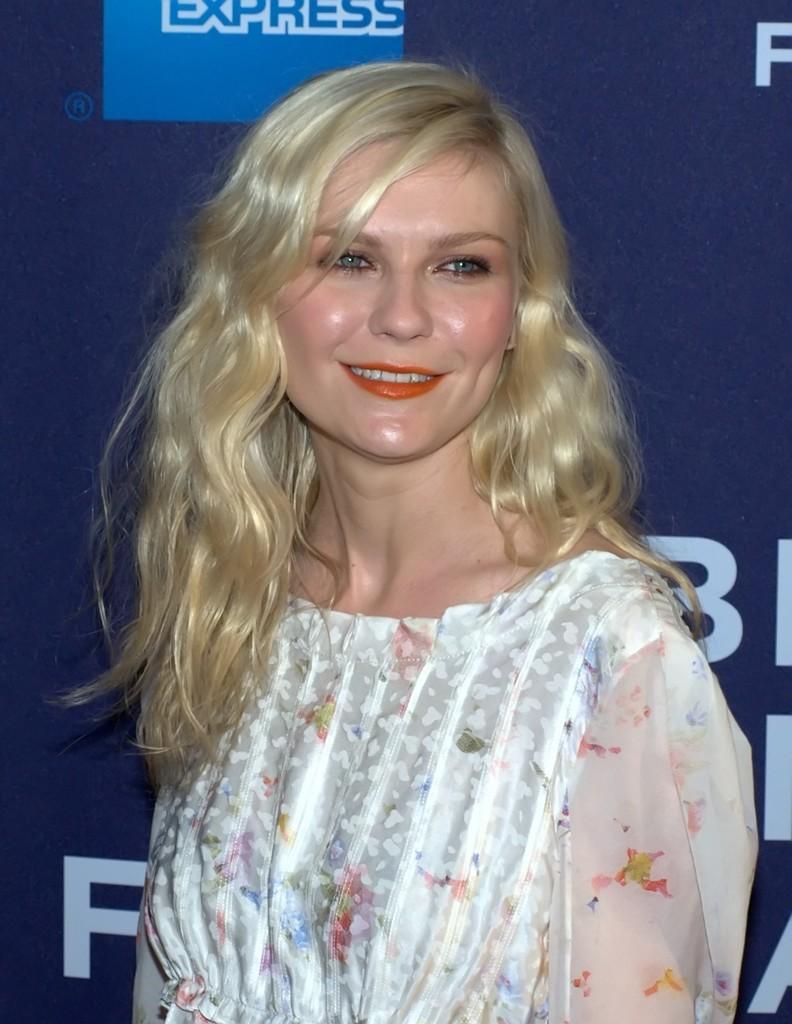Please provide a concise description of this image. There is a lady standing and smiling. In the back there is a blue wall with something written on that. 